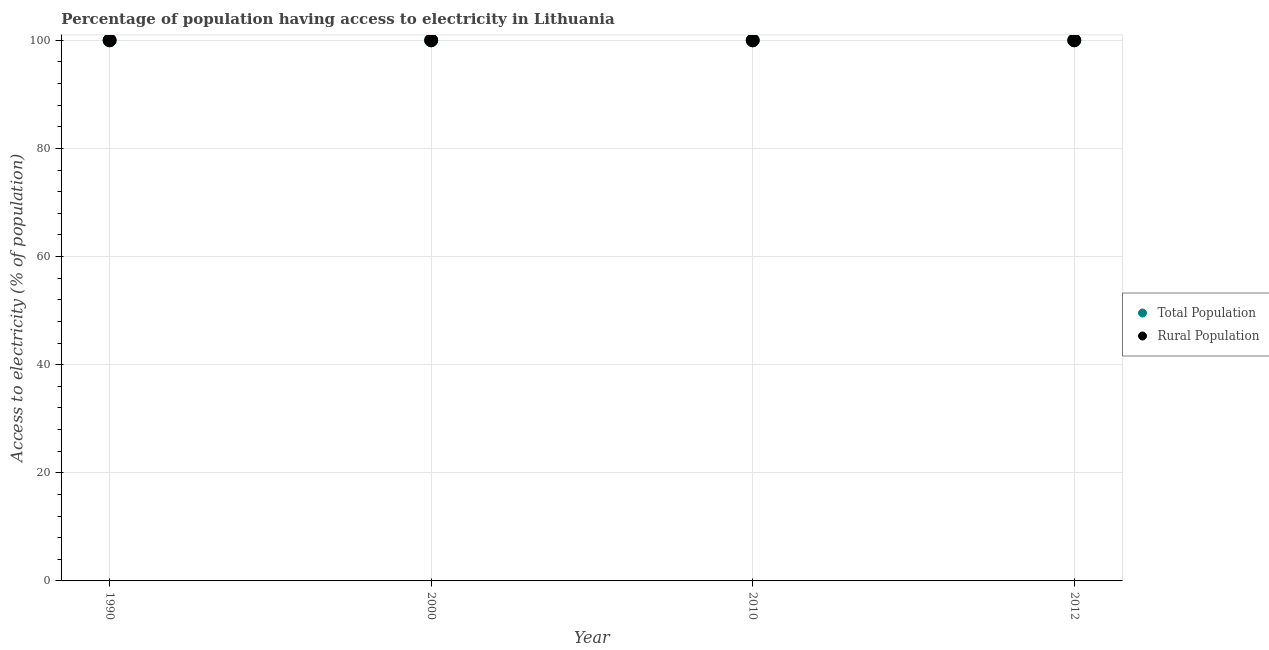How many different coloured dotlines are there?
Ensure brevity in your answer.  2. Is the number of dotlines equal to the number of legend labels?
Your answer should be compact. Yes. What is the percentage of population having access to electricity in 2012?
Offer a terse response. 100. Across all years, what is the maximum percentage of rural population having access to electricity?
Your answer should be very brief. 100. Across all years, what is the minimum percentage of population having access to electricity?
Make the answer very short. 100. What is the total percentage of population having access to electricity in the graph?
Your response must be concise. 400. What is the difference between the percentage of rural population having access to electricity in 2012 and the percentage of population having access to electricity in 1990?
Provide a short and direct response. 0. What is the average percentage of rural population having access to electricity per year?
Offer a terse response. 100. Is the percentage of rural population having access to electricity in 1990 less than that in 2010?
Your answer should be compact. No. Is the difference between the percentage of population having access to electricity in 1990 and 2012 greater than the difference between the percentage of rural population having access to electricity in 1990 and 2012?
Offer a terse response. No. What is the difference between the highest and the second highest percentage of population having access to electricity?
Ensure brevity in your answer.  0. Is the sum of the percentage of population having access to electricity in 2000 and 2012 greater than the maximum percentage of rural population having access to electricity across all years?
Your answer should be compact. Yes. Does the percentage of population having access to electricity monotonically increase over the years?
Give a very brief answer. No. How many dotlines are there?
Your response must be concise. 2. Are the values on the major ticks of Y-axis written in scientific E-notation?
Give a very brief answer. No. Does the graph contain any zero values?
Provide a short and direct response. No. Does the graph contain grids?
Give a very brief answer. Yes. Where does the legend appear in the graph?
Provide a short and direct response. Center right. What is the title of the graph?
Your answer should be compact. Percentage of population having access to electricity in Lithuania. What is the label or title of the Y-axis?
Your response must be concise. Access to electricity (% of population). What is the Access to electricity (% of population) in Total Population in 1990?
Give a very brief answer. 100. What is the Access to electricity (% of population) in Rural Population in 2012?
Offer a terse response. 100. Across all years, what is the maximum Access to electricity (% of population) of Total Population?
Your response must be concise. 100. Across all years, what is the maximum Access to electricity (% of population) of Rural Population?
Ensure brevity in your answer.  100. What is the total Access to electricity (% of population) of Total Population in the graph?
Your answer should be very brief. 400. What is the difference between the Access to electricity (% of population) in Total Population in 1990 and that in 2010?
Your response must be concise. 0. What is the difference between the Access to electricity (% of population) in Rural Population in 1990 and that in 2010?
Your answer should be very brief. 0. What is the difference between the Access to electricity (% of population) of Rural Population in 2000 and that in 2010?
Offer a terse response. 0. What is the difference between the Access to electricity (% of population) in Total Population in 2010 and that in 2012?
Provide a succinct answer. 0. What is the difference between the Access to electricity (% of population) in Total Population in 1990 and the Access to electricity (% of population) in Rural Population in 2012?
Offer a terse response. 0. What is the difference between the Access to electricity (% of population) in Total Population in 2000 and the Access to electricity (% of population) in Rural Population in 2012?
Give a very brief answer. 0. What is the average Access to electricity (% of population) in Total Population per year?
Ensure brevity in your answer.  100. In the year 1990, what is the difference between the Access to electricity (% of population) in Total Population and Access to electricity (% of population) in Rural Population?
Give a very brief answer. 0. What is the ratio of the Access to electricity (% of population) of Rural Population in 1990 to that in 2010?
Provide a short and direct response. 1. What is the ratio of the Access to electricity (% of population) of Total Population in 1990 to that in 2012?
Offer a very short reply. 1. What is the ratio of the Access to electricity (% of population) in Rural Population in 2000 to that in 2010?
Offer a very short reply. 1. What is the ratio of the Access to electricity (% of population) in Rural Population in 2000 to that in 2012?
Your answer should be very brief. 1. What is the ratio of the Access to electricity (% of population) in Rural Population in 2010 to that in 2012?
Offer a very short reply. 1. What is the difference between the highest and the second highest Access to electricity (% of population) of Total Population?
Provide a succinct answer. 0. What is the difference between the highest and the second highest Access to electricity (% of population) in Rural Population?
Make the answer very short. 0. What is the difference between the highest and the lowest Access to electricity (% of population) of Total Population?
Keep it short and to the point. 0. What is the difference between the highest and the lowest Access to electricity (% of population) of Rural Population?
Offer a terse response. 0. 